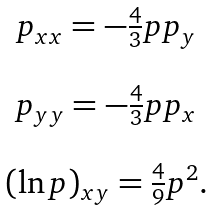Convert formula to latex. <formula><loc_0><loc_0><loc_500><loc_500>\begin{array} { c } p _ { x x } = - \frac { 4 } { 3 } p p _ { y } \\ \\ p _ { y y } = - \frac { 4 } { 3 } p p _ { x } \\ \\ ( \ln p ) _ { x y } = \frac { 4 } { 9 } p ^ { 2 } . \end{array}</formula> 